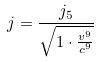Convert formula to latex. <formula><loc_0><loc_0><loc_500><loc_500>j = \frac { j _ { 5 } } { \sqrt { 1 \cdot \frac { v ^ { 9 } } { c ^ { 9 } } } }</formula> 